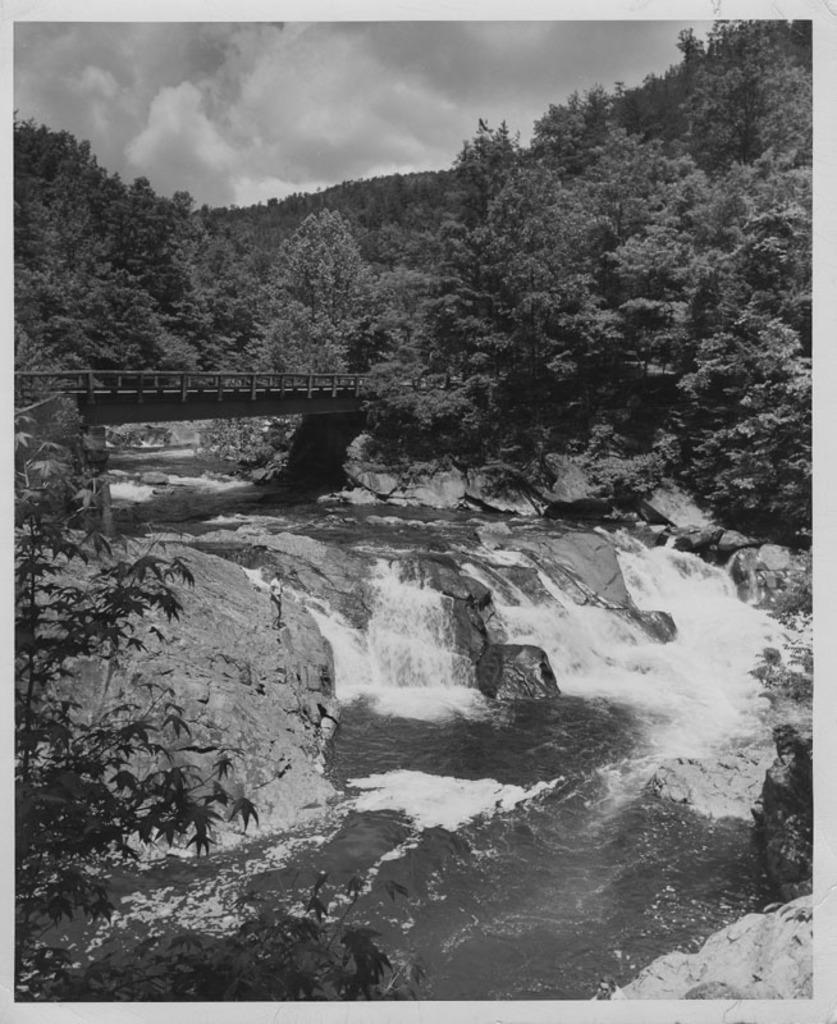Could you give a brief overview of what you see in this image? In this image I can see water, number of trees, clouds, the sky and a bridge over there. I can also see this image is black and white in color. 